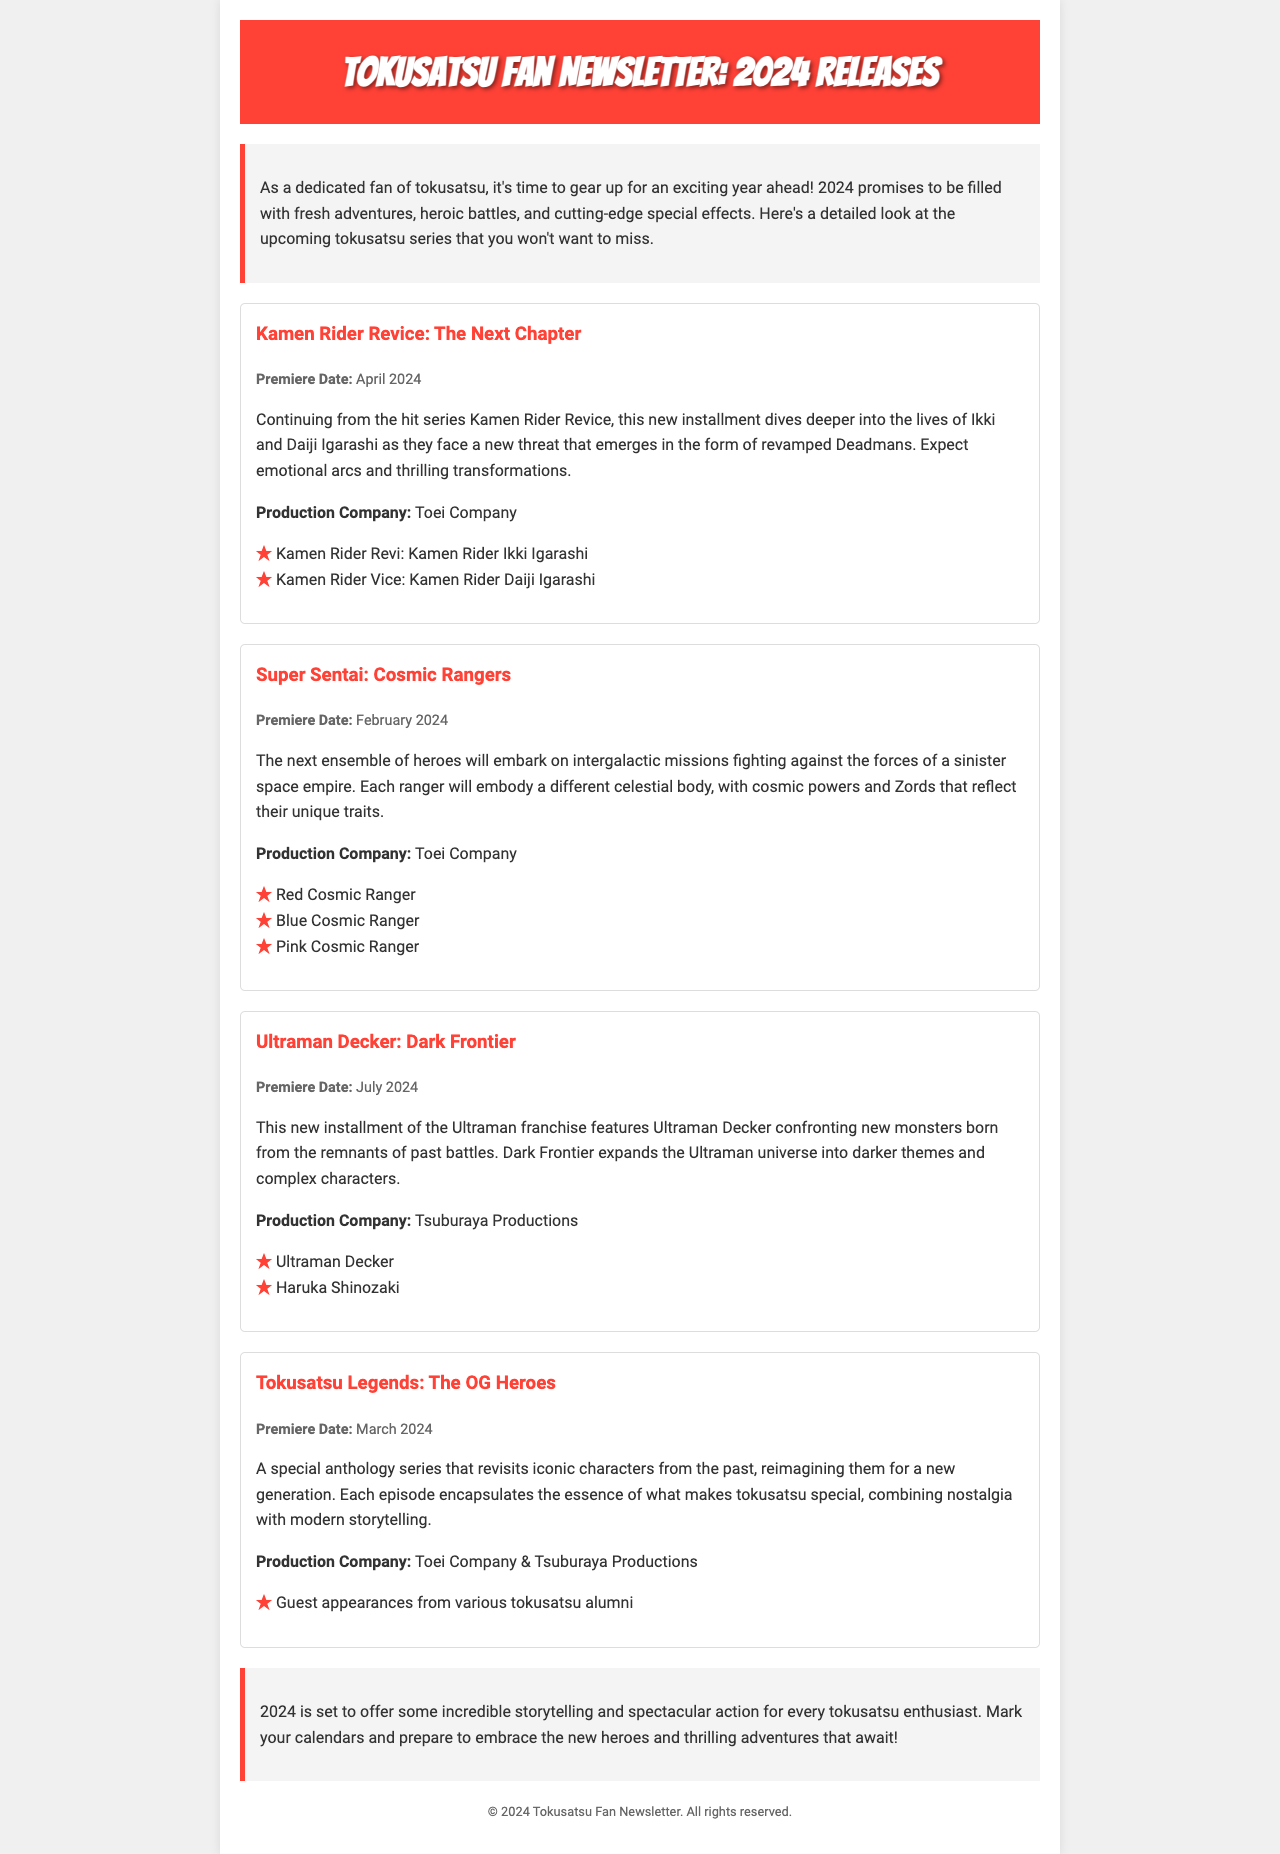what is the premiere date of Kamen Rider Revice: The Next Chapter? The premiere date for Kamen Rider Revice: The Next Chapter is stated in the document as April 2024.
Answer: April 2024 who is the production company for Super Sentai: Cosmic Rangers? The production company for Super Sentai: Cosmic Rangers is Toei Company, which is mentioned in the series section.
Answer: Toei Company how many main characters are listed for Ultraman Decker: Dark Frontier? The document lists two main characters for Ultraman Decker: Dark Frontier under the cast list.
Answer: Two what theme is explored in Ultraman Decker: Dark Frontier? The document mentions that Dark Frontier expands the Ultraman universe into darker themes and complex characters.
Answer: Darker themes which series has a premiere date in March 2024? The document clearly outlines that Tokusatsu Legends: The OG Heroes has a premiere date in March 2024.
Answer: Tokusatsu Legends: The OG Heroes what narrative element does Tokusatsu Legends focus on? The document describes Tokusatsu Legends as an anthology series that revisits iconic characters, emphasizing nostalgia and modern storytelling.
Answer: Nostalgia who are the main characters in Kamen Rider Revice: The Next Chapter? The main characters listed are Kamen Rider Revi (Ikki Igarashi) and Kamen Rider Vice (Daiji Igarashi).
Answer: Kamen Rider Revi and Kamen Rider Vice how does the document classify itself? The document is a newsletter focused on upcoming tokusatsu series releases for 2024, providing detailed information.
Answer: Newsletter 